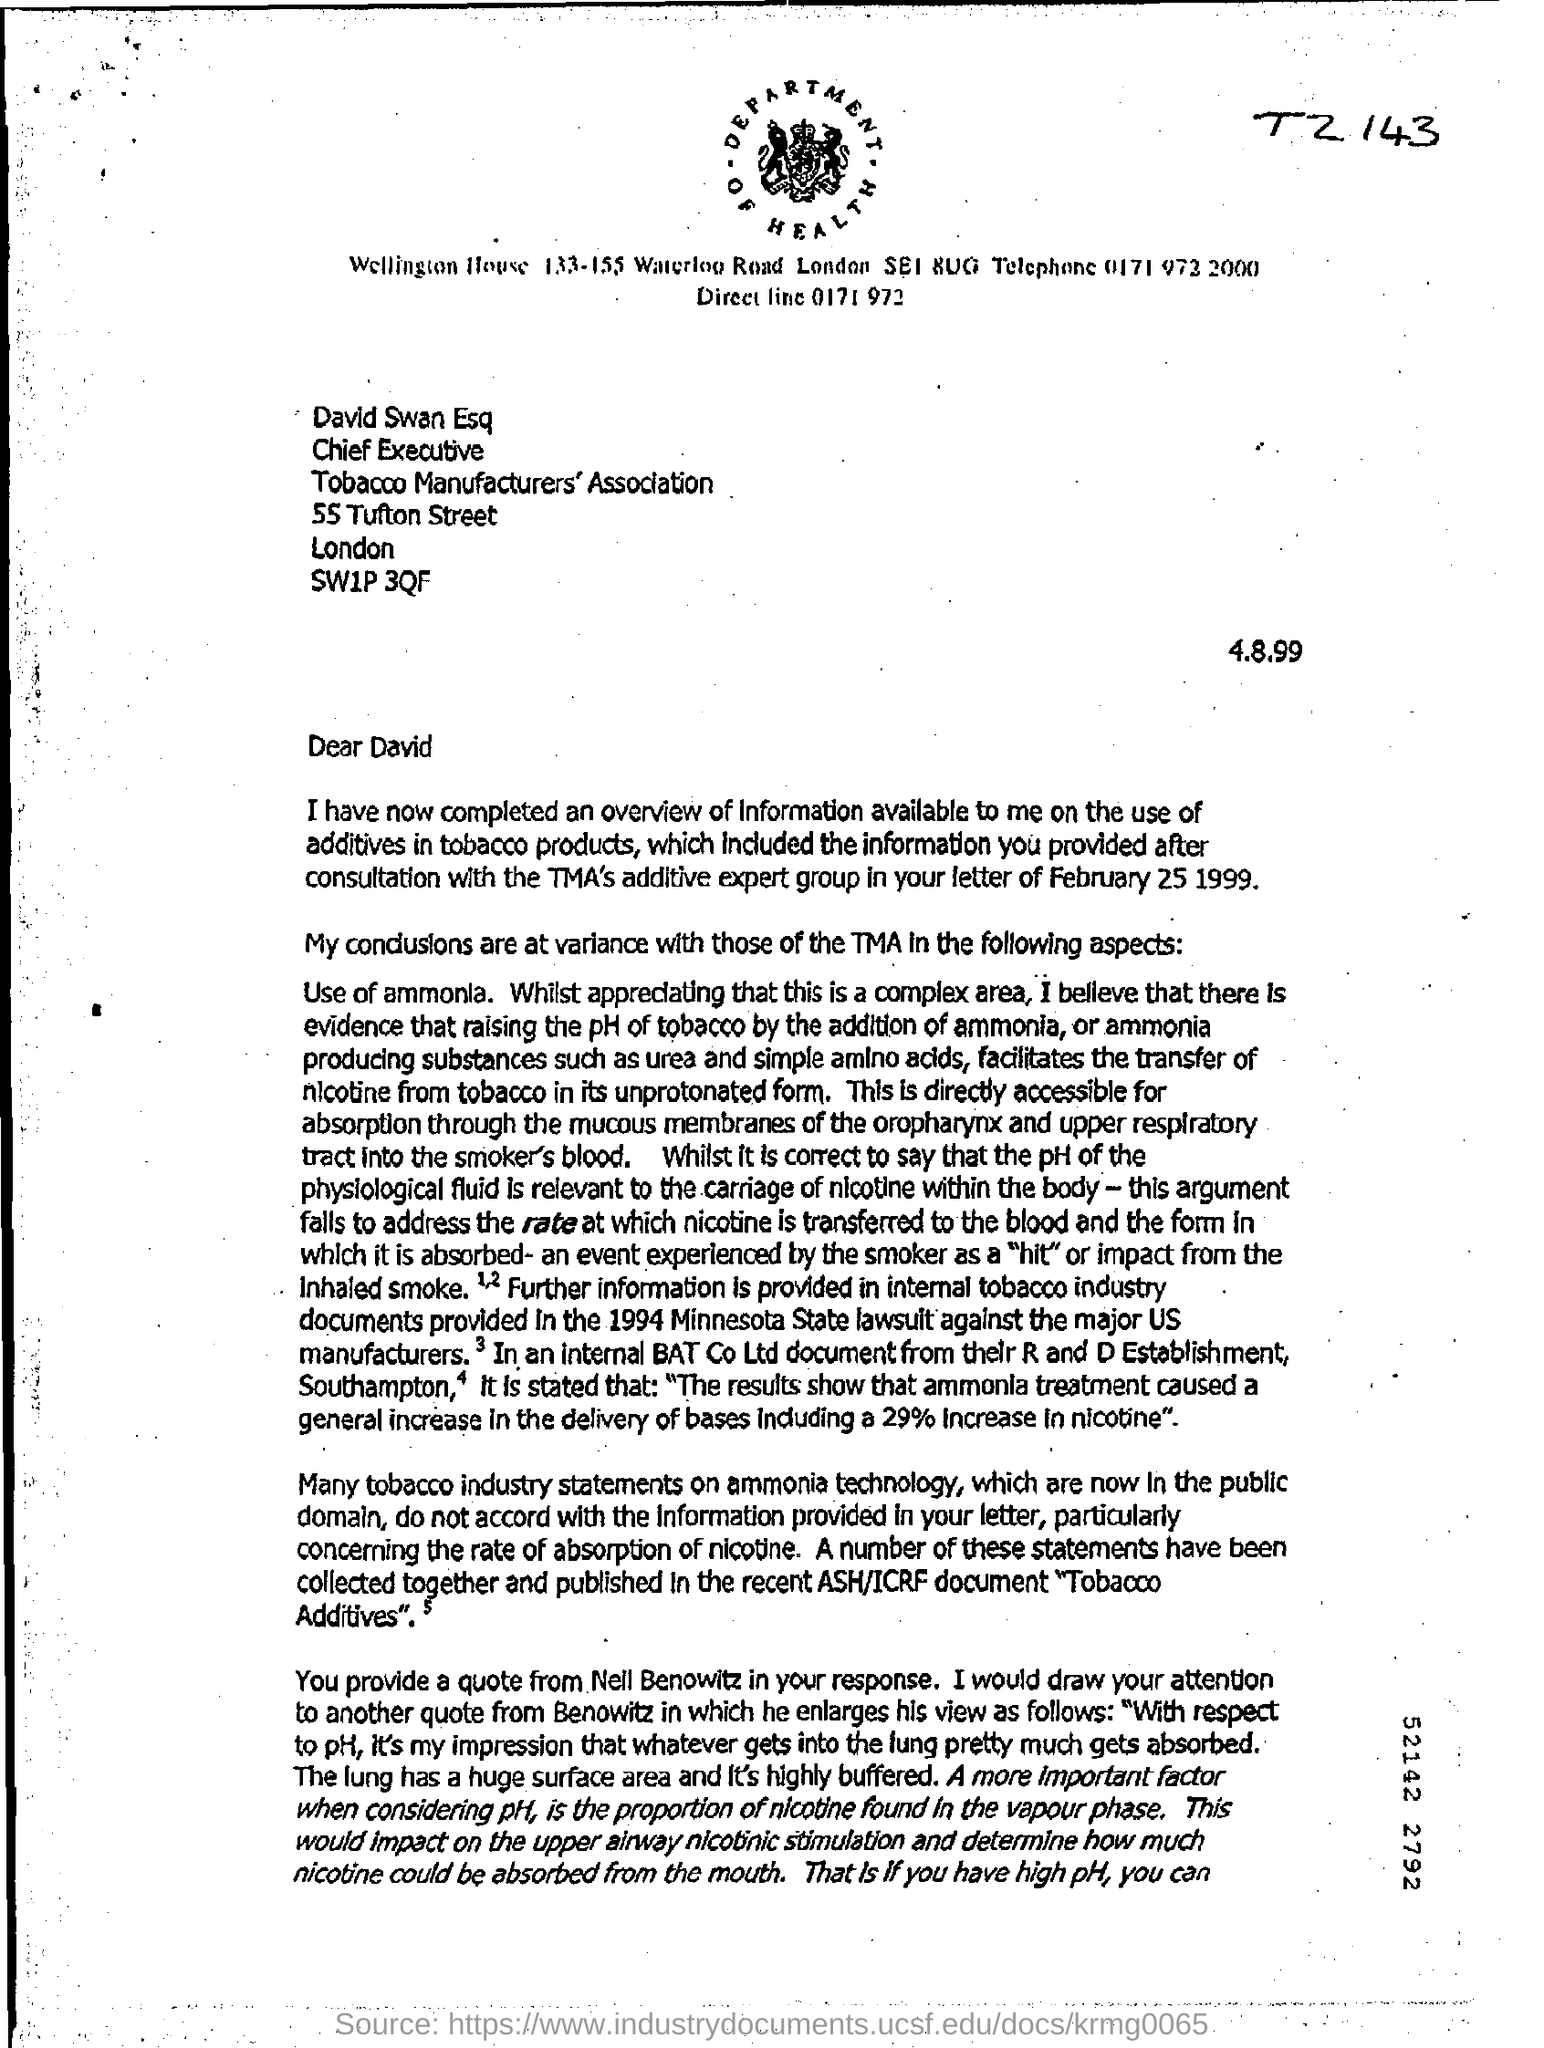What is the position of david swan esq?
Make the answer very short. Chief Executive. Mention the street address of tobacco manufacturers' association ?
Your answer should be compact. 55 Tufton street. 